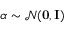Convert formula to latex. <formula><loc_0><loc_0><loc_500><loc_500>\boldsymbol \alpha \sim \mathcal { N } ( { 0 , I } )</formula> 